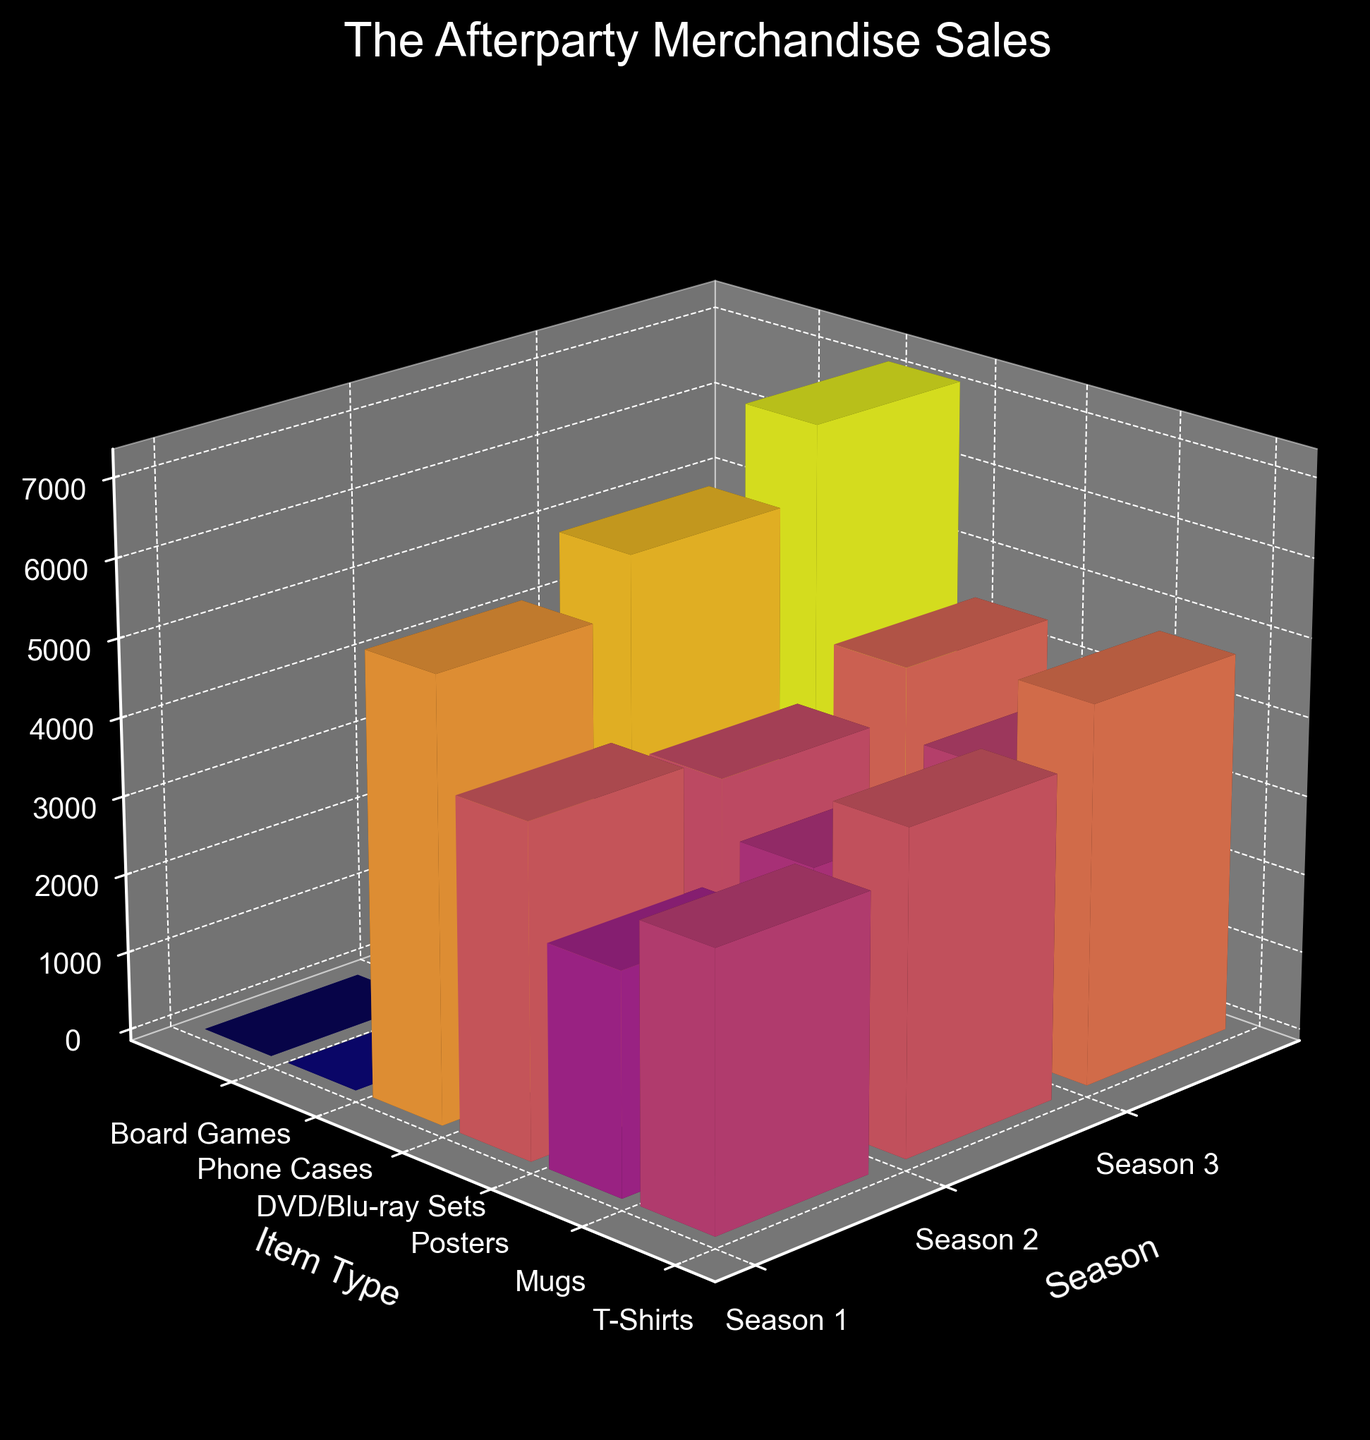What is the title of the plot? The title is usually displayed at the top of the plot. Here, it clearly reads "The Afterparty Merchandise Sales".
Answer: The Afterparty Merchandise Sales Which season had the highest sales for T-Shirts? To determine this, we compare the height of the bars representing T-Shirt sales across different seasons. The tallest bar corresponds to Season 3.
Answer: Season 3 How many item types are listed for Season 2? We count the number of different colored bars along the Season 2 axis. There are five item types for Season 2.
Answer: 5 What are the axis labels in the plot? Axis labels help identify what each axis represents. They are usually found beside the axes. The X-axis is labeled "Season", the Y-axis is labeled "Item Type", and the Z-axis is labeled "Sales".
Answer: Season, Item Type, Sales Which item type had the lowest sales in Season 3? We compare the heights of the bars for each item type in Season 3. The shortest bar is for Board Games.
Answer: Board Games Which season had the highest total merchandise sales? To determine the highest total sales, we sum the heights of all bars for each season. The highest total corresponds to Season 3.
Answer: Season 3 How did the sales of DVD/Blu-ray Sets change from Season 1 to Season 3? We observe the heights of the bars representing DVD/Blu-ray Sets across the three seasons. The sales increased from 5600 in Season 1 to 7200 in Season 3.
Answer: Increased What's the total sales for Posters across all seasons? We sum the sales for Posters from each season: 4200 (Season 1) + 3900 (Season 2) + 4500 (Season 3). The total sales amount to 12600.
Answer: 12600 Which new item type was introduced in Season 3? We identify items that appear in Season 3 but not in previous seasons. Phone Cases and Board Games were not in Season 1, and Board Games is new in Season 3.
Answer: Board Games 